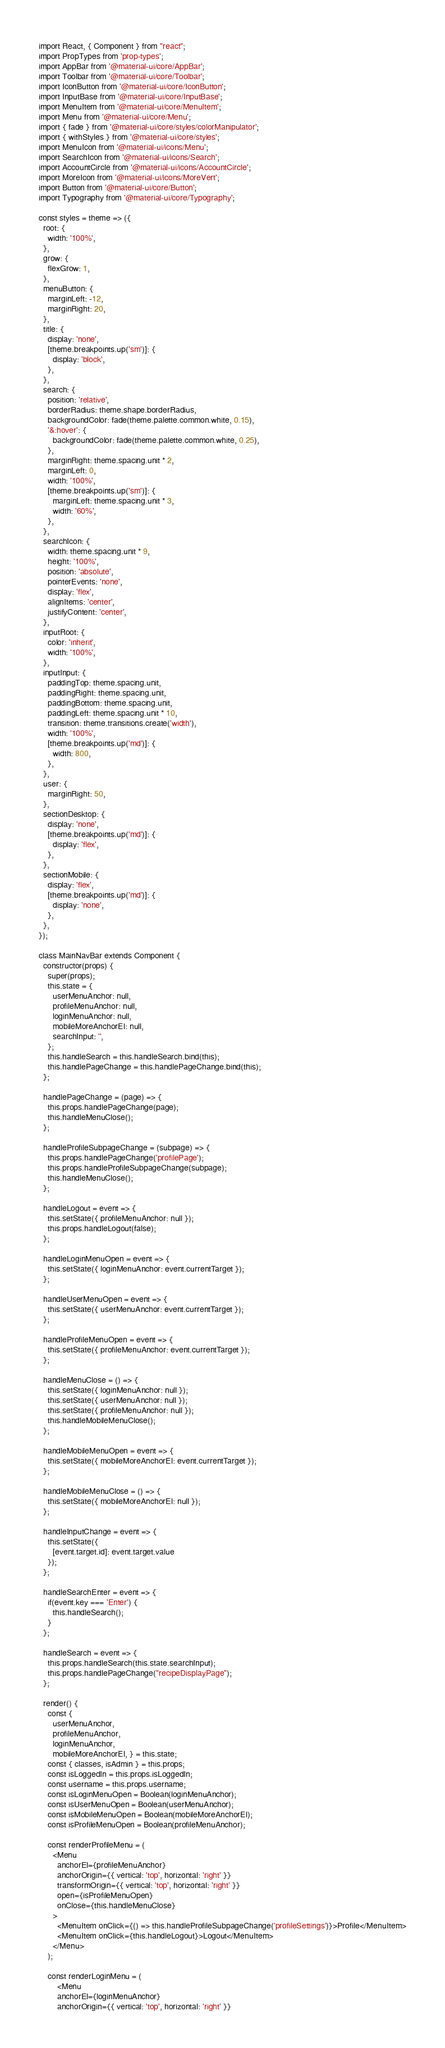<code> <loc_0><loc_0><loc_500><loc_500><_JavaScript_>import React, { Component } from "react";
import PropTypes from 'prop-types';
import AppBar from '@material-ui/core/AppBar';
import Toolbar from '@material-ui/core/Toolbar';
import IconButton from '@material-ui/core/IconButton';
import InputBase from '@material-ui/core/InputBase';
import MenuItem from '@material-ui/core/MenuItem';
import Menu from '@material-ui/core/Menu';
import { fade } from '@material-ui/core/styles/colorManipulator';
import { withStyles } from '@material-ui/core/styles';
import MenuIcon from '@material-ui/icons/Menu';
import SearchIcon from '@material-ui/icons/Search';
import AccountCircle from '@material-ui/icons/AccountCircle';
import MoreIcon from '@material-ui/icons/MoreVert';
import Button from '@material-ui/core/Button';
import Typography from '@material-ui/core/Typography';

const styles = theme => ({
  root: {
    width: '100%',
  },
  grow: {
    flexGrow: 1,
  },
  menuButton: {
    marginLeft: -12,
    marginRight: 20,
  },
  title: {
    display: 'none',
    [theme.breakpoints.up('sm')]: {
      display: 'block',
    },
  },
  search: {
    position: 'relative',
    borderRadius: theme.shape.borderRadius,
    backgroundColor: fade(theme.palette.common.white, 0.15),
    '&:hover': {
      backgroundColor: fade(theme.palette.common.white, 0.25),
    },
    marginRight: theme.spacing.unit * 2,
    marginLeft: 0,
    width: '100%',
    [theme.breakpoints.up('sm')]: {
      marginLeft: theme.spacing.unit * 3,
      width: '60%',
    },
  },
  searchIcon: {
    width: theme.spacing.unit * 9,
    height: '100%',
    position: 'absolute',
    pointerEvents: 'none',
    display: 'flex',
    alignItems: 'center',
    justifyContent: 'center',
  },
  inputRoot: {
    color: 'inherit',
    width: '100%',
  },
  inputInput: {
    paddingTop: theme.spacing.unit,
    paddingRight: theme.spacing.unit,
    paddingBottom: theme.spacing.unit,
    paddingLeft: theme.spacing.unit * 10,
    transition: theme.transitions.create('width'),
    width: '100%',
    [theme.breakpoints.up('md')]: {
      width: 800,
    },
  },
  user: {
    marginRight: 50,
  },
  sectionDesktop: {
    display: 'none',
    [theme.breakpoints.up('md')]: {
      display: 'flex',
    },
  },
  sectionMobile: {
    display: 'flex',
    [theme.breakpoints.up('md')]: {
      display: 'none',
    },
  },
});

class MainNavBar extends Component {
  constructor(props) {
  	super(props);
    this.state = {
      userMenuAnchor: null,
      profileMenuAnchor: null,
      loginMenuAnchor: null,
      mobileMoreAnchorEl: null,
      searchInput: '',
    };
    this.handleSearch = this.handleSearch.bind(this);
    this.handlePageChange = this.handlePageChange.bind(this);
  };

  handlePageChange = (page) => {
    this.props.handlePageChange(page);
    this.handleMenuClose();
  };

  handleProfileSubpageChange = (subpage) => {
    this.props.handlePageChange('profilePage');
    this.props.handleProfileSubpageChange(subpage);
    this.handleMenuClose();
  };

  handleLogout = event => {
  	this.setState({ profileMenuAnchor: null });
  	this.props.handleLogout(false);
  };

  handleLoginMenuOpen = event => {
  	this.setState({ loginMenuAnchor: event.currentTarget });
  };

  handleUserMenuOpen = event => {
    this.setState({ userMenuAnchor: event.currentTarget });
  };

  handleProfileMenuOpen = event => {
    this.setState({ profileMenuAnchor: event.currentTarget });
  };

  handleMenuClose = () => {
    this.setState({ loginMenuAnchor: null });
    this.setState({ userMenuAnchor: null });
    this.setState({ profileMenuAnchor: null });
    this.handleMobileMenuClose();
  };

  handleMobileMenuOpen = event => {
    this.setState({ mobileMoreAnchorEl: event.currentTarget });
  };

  handleMobileMenuClose = () => {
    this.setState({ mobileMoreAnchorEl: null });
  };

  handleInputChange = event => {
    this.setState({
      [event.target.id]: event.target.value
    });
  };

  handleSearchEnter = event => {
    if(event.key === 'Enter') {
      this.handleSearch();
    }
  };

  handleSearch = event => {
    this.props.handleSearch(this.state.searchInput);
    this.props.handlePageChange("recipeDisplayPage");
  };

  render() {
    const { 
      userMenuAnchor, 
      profileMenuAnchor, 
      loginMenuAnchor, 
      mobileMoreAnchorEl, } = this.state;
    const { classes, isAdmin } = this.props;
    const isLoggedIn = this.props.isLoggedIn;
    const username = this.props.username;
    const isLoginMenuOpen = Boolean(loginMenuAnchor);
    const isUserMenuOpen = Boolean(userMenuAnchor);
    const isMobileMenuOpen = Boolean(mobileMoreAnchorEl);  
    const isProfileMenuOpen = Boolean(profileMenuAnchor);  

    const renderProfileMenu = (
      <Menu
        anchorEl={profileMenuAnchor}
        anchorOrigin={{ vertical: 'top', horizontal: 'right' }}
        transformOrigin={{ vertical: 'top', horizontal: 'right' }}
        open={isProfileMenuOpen}
        onClose={this.handleMenuClose}
      >
        <MenuItem onClick={() => this.handleProfileSubpageChange('profileSettings')}>Profile</MenuItem>
        <MenuItem onClick={this.handleLogout}>Logout</MenuItem>
      </Menu>
    );

    const renderLoginMenu = (
    	<Menu
      	anchorEl={loginMenuAnchor}
      	anchorOrigin={{ vertical: 'top', horizontal: 'right' }}</code> 